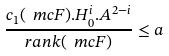Convert formula to latex. <formula><loc_0><loc_0><loc_500><loc_500>\frac { c _ { 1 } ( \ m c { F } ) . H _ { 0 } ^ { i } . A ^ { 2 - i } } { r a n k ( \ m c { F } ) } \leq a</formula> 